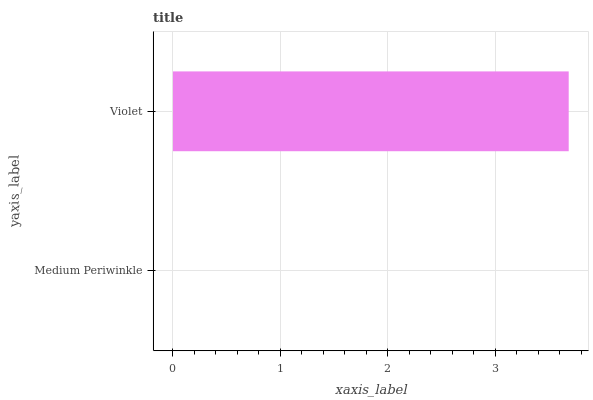Is Medium Periwinkle the minimum?
Answer yes or no. Yes. Is Violet the maximum?
Answer yes or no. Yes. Is Violet the minimum?
Answer yes or no. No. Is Violet greater than Medium Periwinkle?
Answer yes or no. Yes. Is Medium Periwinkle less than Violet?
Answer yes or no. Yes. Is Medium Periwinkle greater than Violet?
Answer yes or no. No. Is Violet less than Medium Periwinkle?
Answer yes or no. No. Is Violet the high median?
Answer yes or no. Yes. Is Medium Periwinkle the low median?
Answer yes or no. Yes. Is Medium Periwinkle the high median?
Answer yes or no. No. Is Violet the low median?
Answer yes or no. No. 